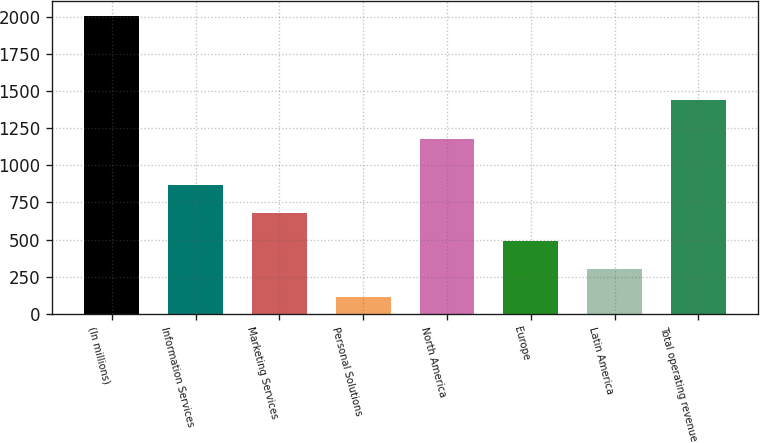Convert chart to OTSL. <chart><loc_0><loc_0><loc_500><loc_500><bar_chart><fcel>(In millions)<fcel>Information Services<fcel>Marketing Services<fcel>Personal Solutions<fcel>North America<fcel>Europe<fcel>Latin America<fcel>Total operating revenue<nl><fcel>2005<fcel>870.82<fcel>681.79<fcel>114.7<fcel>1174.7<fcel>492.76<fcel>303.73<fcel>1443.4<nl></chart> 